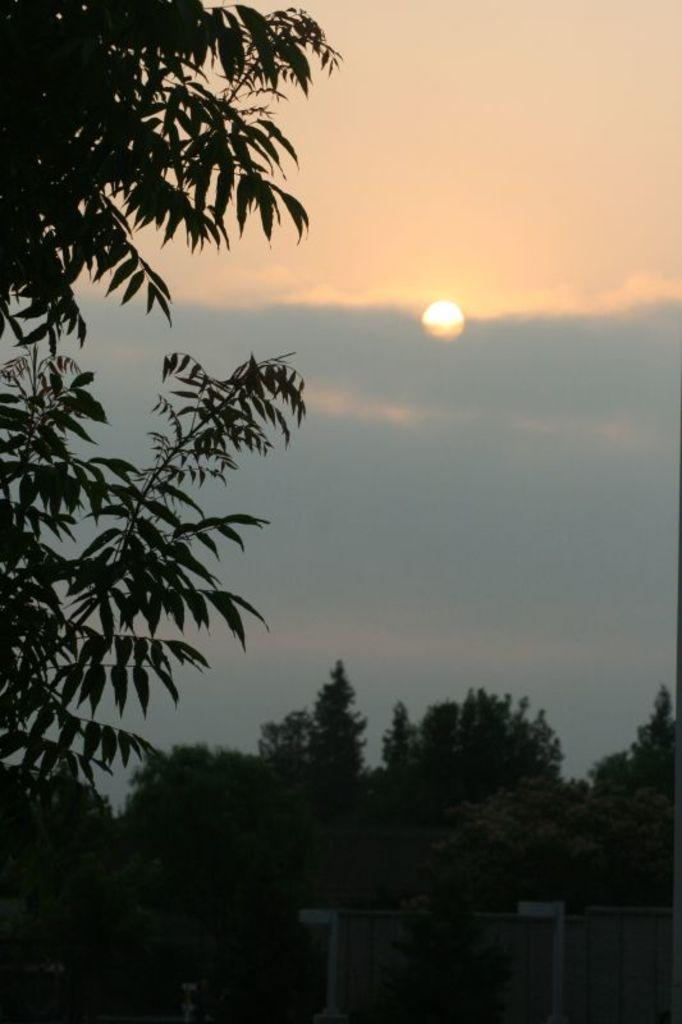What type of vegetation can be seen in the image? There are trees in the image. What is visible in the background of the image? The sky is visible in the image. What colors are present in the sky? The sky has blue and white colors. Can you hear the song being sung by the nut in the image? There is no nut or song present in the image; it features trees and a sky with blue and white colors. 